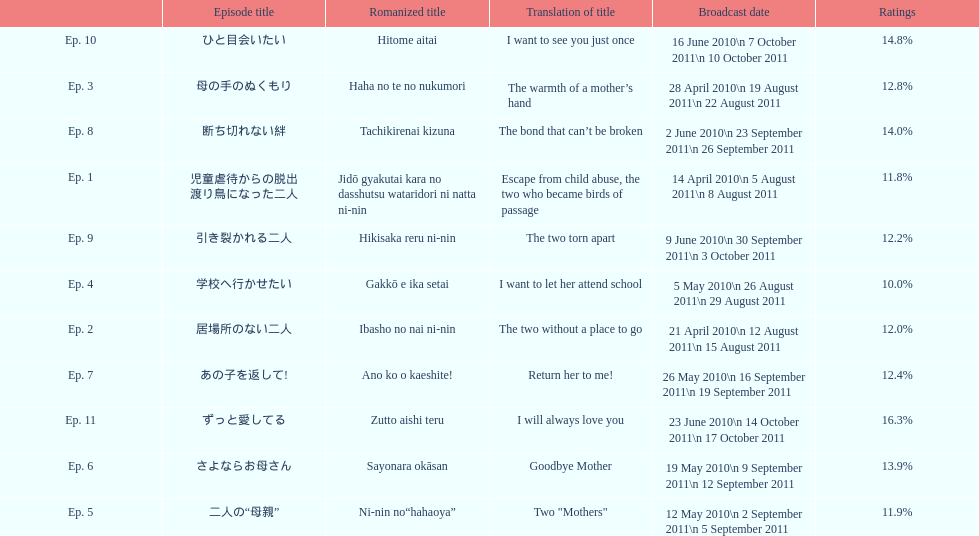What was the name of the first episode of this show? 児童虐待からの脱出 渡り鳥になった二人. 